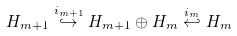Convert formula to latex. <formula><loc_0><loc_0><loc_500><loc_500>H _ { m + 1 } \overset { i _ { m + 1 } } \hookrightarrow H _ { m + 1 } \oplus H _ { m } \overset { i _ { m } } \hookleftarrow H _ { m }</formula> 